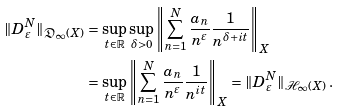<formula> <loc_0><loc_0><loc_500><loc_500>\| D ^ { N } _ { \varepsilon } \| _ { \mathfrak { D } _ { \infty } ( X ) } & = \sup _ { t \in \mathbb { R } } \sup _ { \delta > 0 } { \left \| \sum _ { n = 1 } ^ { N } { \frac { a _ { n } } { n ^ { \varepsilon } } \frac { 1 } { n ^ { \delta + i t } } } \right \| _ { X } } \\ & = \sup _ { t \in \mathbb { R } } { \left \| \sum _ { n = 1 } ^ { N } { \frac { a _ { n } } { n ^ { \varepsilon } } \frac { 1 } { n ^ { i t } } } \right \| _ { X } } = \| D ^ { N } _ { \varepsilon } \| _ { \mathcal { H } _ { \infty } ( X ) } \, .</formula> 